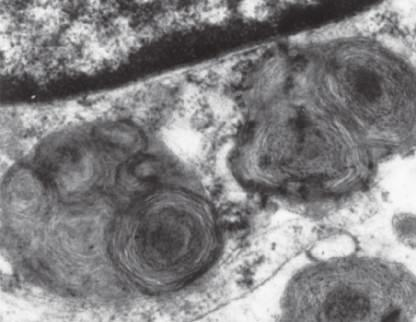does a portion of a neuron under the electron microscope show prominent lysosomes with whorled configurations just below part of the nucleus?
Answer the question using a single word or phrase. Yes 